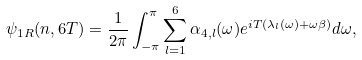<formula> <loc_0><loc_0><loc_500><loc_500>\psi _ { 1 R } ( n , 6 T ) = \frac { 1 } { 2 \pi } \int _ { - \pi } ^ { \pi } \sum _ { l = 1 } ^ { 6 } \alpha _ { 4 , l } ( \omega ) e ^ { i T ( \lambda _ { l } ( \omega ) + \omega \beta ) } d \omega ,</formula> 